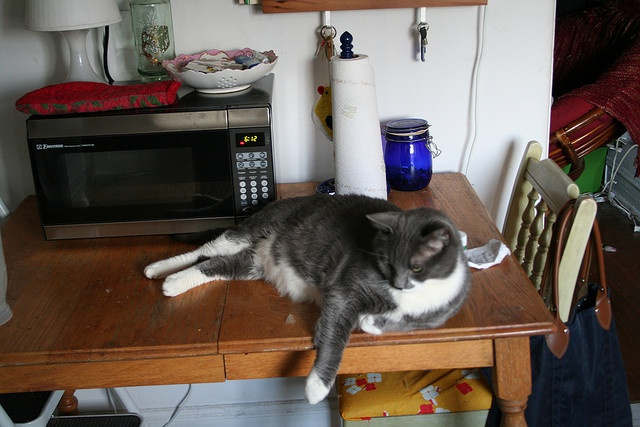Describe the objects in this image and their specific colors. I can see dining table in gray, maroon, black, and brown tones, microwave in gray, black, and darkgray tones, cat in gray, black, lightgray, and darkgray tones, handbag in gray, black, and maroon tones, and chair in gray, black, darkgray, and beige tones in this image. 